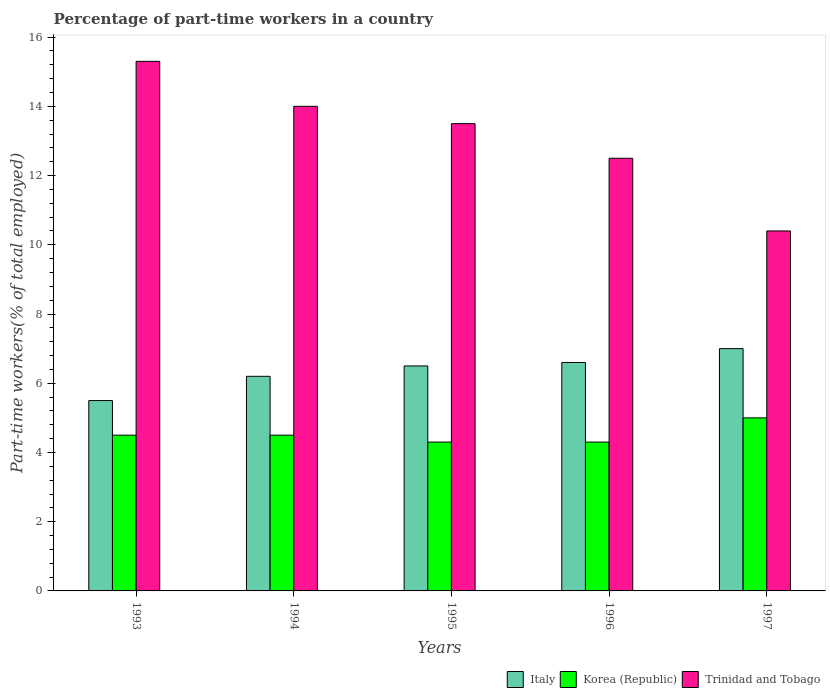How many different coloured bars are there?
Your answer should be compact. 3. How many groups of bars are there?
Give a very brief answer. 5. How many bars are there on the 3rd tick from the left?
Provide a short and direct response. 3. How many bars are there on the 2nd tick from the right?
Your answer should be very brief. 3. In how many cases, is the number of bars for a given year not equal to the number of legend labels?
Keep it short and to the point. 0. Across all years, what is the maximum percentage of part-time workers in Korea (Republic)?
Make the answer very short. 5. Across all years, what is the minimum percentage of part-time workers in Korea (Republic)?
Give a very brief answer. 4.3. In which year was the percentage of part-time workers in Korea (Republic) maximum?
Provide a succinct answer. 1997. In which year was the percentage of part-time workers in Trinidad and Tobago minimum?
Provide a succinct answer. 1997. What is the total percentage of part-time workers in Italy in the graph?
Make the answer very short. 31.8. What is the difference between the percentage of part-time workers in Korea (Republic) in 1993 and that in 1997?
Keep it short and to the point. -0.5. What is the average percentage of part-time workers in Korea (Republic) per year?
Give a very brief answer. 4.52. In the year 1997, what is the difference between the percentage of part-time workers in Italy and percentage of part-time workers in Trinidad and Tobago?
Keep it short and to the point. -3.4. In how many years, is the percentage of part-time workers in Trinidad and Tobago greater than 0.4 %?
Keep it short and to the point. 5. What is the ratio of the percentage of part-time workers in Korea (Republic) in 1993 to that in 1995?
Offer a terse response. 1.05. Is the percentage of part-time workers in Italy in 1993 less than that in 1996?
Your answer should be compact. Yes. Is the difference between the percentage of part-time workers in Italy in 1993 and 1996 greater than the difference between the percentage of part-time workers in Trinidad and Tobago in 1993 and 1996?
Provide a succinct answer. No. What is the difference between the highest and the second highest percentage of part-time workers in Italy?
Make the answer very short. 0.4. What is the difference between the highest and the lowest percentage of part-time workers in Korea (Republic)?
Ensure brevity in your answer.  0.7. What does the 3rd bar from the left in 1997 represents?
Ensure brevity in your answer.  Trinidad and Tobago. What does the 1st bar from the right in 1993 represents?
Offer a very short reply. Trinidad and Tobago. Is it the case that in every year, the sum of the percentage of part-time workers in Korea (Republic) and percentage of part-time workers in Trinidad and Tobago is greater than the percentage of part-time workers in Italy?
Your answer should be compact. Yes. How many bars are there?
Your answer should be compact. 15. What is the difference between two consecutive major ticks on the Y-axis?
Offer a very short reply. 2. Are the values on the major ticks of Y-axis written in scientific E-notation?
Ensure brevity in your answer.  No. Does the graph contain any zero values?
Keep it short and to the point. No. Where does the legend appear in the graph?
Your answer should be very brief. Bottom right. What is the title of the graph?
Your answer should be very brief. Percentage of part-time workers in a country. What is the label or title of the Y-axis?
Make the answer very short. Part-time workers(% of total employed). What is the Part-time workers(% of total employed) in Italy in 1993?
Give a very brief answer. 5.5. What is the Part-time workers(% of total employed) of Korea (Republic) in 1993?
Your answer should be very brief. 4.5. What is the Part-time workers(% of total employed) of Trinidad and Tobago in 1993?
Offer a terse response. 15.3. What is the Part-time workers(% of total employed) of Italy in 1994?
Make the answer very short. 6.2. What is the Part-time workers(% of total employed) of Korea (Republic) in 1995?
Provide a short and direct response. 4.3. What is the Part-time workers(% of total employed) of Trinidad and Tobago in 1995?
Provide a succinct answer. 13.5. What is the Part-time workers(% of total employed) of Italy in 1996?
Offer a very short reply. 6.6. What is the Part-time workers(% of total employed) in Korea (Republic) in 1996?
Offer a very short reply. 4.3. What is the Part-time workers(% of total employed) of Korea (Republic) in 1997?
Ensure brevity in your answer.  5. What is the Part-time workers(% of total employed) in Trinidad and Tobago in 1997?
Offer a very short reply. 10.4. Across all years, what is the maximum Part-time workers(% of total employed) of Korea (Republic)?
Offer a terse response. 5. Across all years, what is the maximum Part-time workers(% of total employed) of Trinidad and Tobago?
Ensure brevity in your answer.  15.3. Across all years, what is the minimum Part-time workers(% of total employed) in Korea (Republic)?
Provide a short and direct response. 4.3. Across all years, what is the minimum Part-time workers(% of total employed) of Trinidad and Tobago?
Make the answer very short. 10.4. What is the total Part-time workers(% of total employed) in Italy in the graph?
Your answer should be compact. 31.8. What is the total Part-time workers(% of total employed) of Korea (Republic) in the graph?
Give a very brief answer. 22.6. What is the total Part-time workers(% of total employed) in Trinidad and Tobago in the graph?
Your answer should be compact. 65.7. What is the difference between the Part-time workers(% of total employed) in Italy in 1993 and that in 1994?
Your answer should be very brief. -0.7. What is the difference between the Part-time workers(% of total employed) of Korea (Republic) in 1993 and that in 1994?
Ensure brevity in your answer.  0. What is the difference between the Part-time workers(% of total employed) in Trinidad and Tobago in 1993 and that in 1994?
Keep it short and to the point. 1.3. What is the difference between the Part-time workers(% of total employed) in Korea (Republic) in 1993 and that in 1995?
Make the answer very short. 0.2. What is the difference between the Part-time workers(% of total employed) in Italy in 1993 and that in 1996?
Offer a very short reply. -1.1. What is the difference between the Part-time workers(% of total employed) in Korea (Republic) in 1993 and that in 1996?
Give a very brief answer. 0.2. What is the difference between the Part-time workers(% of total employed) of Trinidad and Tobago in 1993 and that in 1996?
Make the answer very short. 2.8. What is the difference between the Part-time workers(% of total employed) of Italy in 1993 and that in 1997?
Ensure brevity in your answer.  -1.5. What is the difference between the Part-time workers(% of total employed) in Italy in 1994 and that in 1995?
Make the answer very short. -0.3. What is the difference between the Part-time workers(% of total employed) in Italy in 1994 and that in 1996?
Your response must be concise. -0.4. What is the difference between the Part-time workers(% of total employed) of Korea (Republic) in 1994 and that in 1996?
Your answer should be compact. 0.2. What is the difference between the Part-time workers(% of total employed) of Korea (Republic) in 1994 and that in 1997?
Make the answer very short. -0.5. What is the difference between the Part-time workers(% of total employed) of Trinidad and Tobago in 1994 and that in 1997?
Ensure brevity in your answer.  3.6. What is the difference between the Part-time workers(% of total employed) in Italy in 1995 and that in 1996?
Offer a very short reply. -0.1. What is the difference between the Part-time workers(% of total employed) of Korea (Republic) in 1995 and that in 1997?
Offer a terse response. -0.7. What is the difference between the Part-time workers(% of total employed) of Trinidad and Tobago in 1995 and that in 1997?
Provide a short and direct response. 3.1. What is the difference between the Part-time workers(% of total employed) in Trinidad and Tobago in 1996 and that in 1997?
Make the answer very short. 2.1. What is the difference between the Part-time workers(% of total employed) of Italy in 1993 and the Part-time workers(% of total employed) of Korea (Republic) in 1994?
Your answer should be very brief. 1. What is the difference between the Part-time workers(% of total employed) in Italy in 1993 and the Part-time workers(% of total employed) in Trinidad and Tobago in 1994?
Make the answer very short. -8.5. What is the difference between the Part-time workers(% of total employed) in Korea (Republic) in 1993 and the Part-time workers(% of total employed) in Trinidad and Tobago in 1994?
Offer a very short reply. -9.5. What is the difference between the Part-time workers(% of total employed) of Korea (Republic) in 1993 and the Part-time workers(% of total employed) of Trinidad and Tobago in 1995?
Provide a short and direct response. -9. What is the difference between the Part-time workers(% of total employed) of Italy in 1993 and the Part-time workers(% of total employed) of Korea (Republic) in 1996?
Offer a terse response. 1.2. What is the difference between the Part-time workers(% of total employed) of Italy in 1993 and the Part-time workers(% of total employed) of Trinidad and Tobago in 1996?
Give a very brief answer. -7. What is the difference between the Part-time workers(% of total employed) of Korea (Republic) in 1993 and the Part-time workers(% of total employed) of Trinidad and Tobago in 1996?
Your answer should be very brief. -8. What is the difference between the Part-time workers(% of total employed) of Italy in 1993 and the Part-time workers(% of total employed) of Korea (Republic) in 1997?
Keep it short and to the point. 0.5. What is the difference between the Part-time workers(% of total employed) of Korea (Republic) in 1993 and the Part-time workers(% of total employed) of Trinidad and Tobago in 1997?
Make the answer very short. -5.9. What is the difference between the Part-time workers(% of total employed) in Italy in 1994 and the Part-time workers(% of total employed) in Trinidad and Tobago in 1995?
Ensure brevity in your answer.  -7.3. What is the difference between the Part-time workers(% of total employed) in Korea (Republic) in 1994 and the Part-time workers(% of total employed) in Trinidad and Tobago in 1995?
Give a very brief answer. -9. What is the difference between the Part-time workers(% of total employed) in Italy in 1994 and the Part-time workers(% of total employed) in Korea (Republic) in 1996?
Make the answer very short. 1.9. What is the difference between the Part-time workers(% of total employed) of Italy in 1994 and the Part-time workers(% of total employed) of Trinidad and Tobago in 1997?
Your answer should be very brief. -4.2. What is the difference between the Part-time workers(% of total employed) in Italy in 1995 and the Part-time workers(% of total employed) in Korea (Republic) in 1996?
Offer a terse response. 2.2. What is the difference between the Part-time workers(% of total employed) of Italy in 1995 and the Part-time workers(% of total employed) of Korea (Republic) in 1997?
Your response must be concise. 1.5. What is the difference between the Part-time workers(% of total employed) in Italy in 1995 and the Part-time workers(% of total employed) in Trinidad and Tobago in 1997?
Offer a terse response. -3.9. What is the difference between the Part-time workers(% of total employed) in Korea (Republic) in 1995 and the Part-time workers(% of total employed) in Trinidad and Tobago in 1997?
Your answer should be compact. -6.1. What is the difference between the Part-time workers(% of total employed) in Italy in 1996 and the Part-time workers(% of total employed) in Korea (Republic) in 1997?
Make the answer very short. 1.6. What is the difference between the Part-time workers(% of total employed) of Korea (Republic) in 1996 and the Part-time workers(% of total employed) of Trinidad and Tobago in 1997?
Your response must be concise. -6.1. What is the average Part-time workers(% of total employed) in Italy per year?
Offer a terse response. 6.36. What is the average Part-time workers(% of total employed) in Korea (Republic) per year?
Offer a terse response. 4.52. What is the average Part-time workers(% of total employed) in Trinidad and Tobago per year?
Ensure brevity in your answer.  13.14. In the year 1993, what is the difference between the Part-time workers(% of total employed) of Italy and Part-time workers(% of total employed) of Korea (Republic)?
Your response must be concise. 1. In the year 1993, what is the difference between the Part-time workers(% of total employed) of Korea (Republic) and Part-time workers(% of total employed) of Trinidad and Tobago?
Offer a very short reply. -10.8. In the year 1994, what is the difference between the Part-time workers(% of total employed) of Italy and Part-time workers(% of total employed) of Korea (Republic)?
Offer a terse response. 1.7. In the year 1994, what is the difference between the Part-time workers(% of total employed) in Italy and Part-time workers(% of total employed) in Trinidad and Tobago?
Provide a short and direct response. -7.8. In the year 1994, what is the difference between the Part-time workers(% of total employed) in Korea (Republic) and Part-time workers(% of total employed) in Trinidad and Tobago?
Give a very brief answer. -9.5. In the year 1995, what is the difference between the Part-time workers(% of total employed) in Italy and Part-time workers(% of total employed) in Korea (Republic)?
Make the answer very short. 2.2. In the year 1995, what is the difference between the Part-time workers(% of total employed) of Italy and Part-time workers(% of total employed) of Trinidad and Tobago?
Give a very brief answer. -7. In the year 1995, what is the difference between the Part-time workers(% of total employed) of Korea (Republic) and Part-time workers(% of total employed) of Trinidad and Tobago?
Give a very brief answer. -9.2. In the year 1996, what is the difference between the Part-time workers(% of total employed) of Korea (Republic) and Part-time workers(% of total employed) of Trinidad and Tobago?
Provide a succinct answer. -8.2. In the year 1997, what is the difference between the Part-time workers(% of total employed) in Italy and Part-time workers(% of total employed) in Korea (Republic)?
Give a very brief answer. 2. What is the ratio of the Part-time workers(% of total employed) in Italy in 1993 to that in 1994?
Keep it short and to the point. 0.89. What is the ratio of the Part-time workers(% of total employed) in Korea (Republic) in 1993 to that in 1994?
Provide a succinct answer. 1. What is the ratio of the Part-time workers(% of total employed) of Trinidad and Tobago in 1993 to that in 1994?
Ensure brevity in your answer.  1.09. What is the ratio of the Part-time workers(% of total employed) in Italy in 1993 to that in 1995?
Provide a short and direct response. 0.85. What is the ratio of the Part-time workers(% of total employed) in Korea (Republic) in 1993 to that in 1995?
Make the answer very short. 1.05. What is the ratio of the Part-time workers(% of total employed) in Trinidad and Tobago in 1993 to that in 1995?
Your answer should be very brief. 1.13. What is the ratio of the Part-time workers(% of total employed) of Korea (Republic) in 1993 to that in 1996?
Offer a terse response. 1.05. What is the ratio of the Part-time workers(% of total employed) of Trinidad and Tobago in 1993 to that in 1996?
Your answer should be very brief. 1.22. What is the ratio of the Part-time workers(% of total employed) in Italy in 1993 to that in 1997?
Ensure brevity in your answer.  0.79. What is the ratio of the Part-time workers(% of total employed) of Korea (Republic) in 1993 to that in 1997?
Offer a terse response. 0.9. What is the ratio of the Part-time workers(% of total employed) of Trinidad and Tobago in 1993 to that in 1997?
Provide a succinct answer. 1.47. What is the ratio of the Part-time workers(% of total employed) of Italy in 1994 to that in 1995?
Provide a short and direct response. 0.95. What is the ratio of the Part-time workers(% of total employed) in Korea (Republic) in 1994 to that in 1995?
Make the answer very short. 1.05. What is the ratio of the Part-time workers(% of total employed) in Trinidad and Tobago in 1994 to that in 1995?
Offer a terse response. 1.04. What is the ratio of the Part-time workers(% of total employed) of Italy in 1994 to that in 1996?
Offer a terse response. 0.94. What is the ratio of the Part-time workers(% of total employed) of Korea (Republic) in 1994 to that in 1996?
Your answer should be very brief. 1.05. What is the ratio of the Part-time workers(% of total employed) of Trinidad and Tobago in 1994 to that in 1996?
Your answer should be very brief. 1.12. What is the ratio of the Part-time workers(% of total employed) of Italy in 1994 to that in 1997?
Offer a very short reply. 0.89. What is the ratio of the Part-time workers(% of total employed) of Trinidad and Tobago in 1994 to that in 1997?
Offer a terse response. 1.35. What is the ratio of the Part-time workers(% of total employed) of Italy in 1995 to that in 1996?
Your answer should be compact. 0.98. What is the ratio of the Part-time workers(% of total employed) in Korea (Republic) in 1995 to that in 1997?
Make the answer very short. 0.86. What is the ratio of the Part-time workers(% of total employed) of Trinidad and Tobago in 1995 to that in 1997?
Provide a succinct answer. 1.3. What is the ratio of the Part-time workers(% of total employed) in Italy in 1996 to that in 1997?
Make the answer very short. 0.94. What is the ratio of the Part-time workers(% of total employed) of Korea (Republic) in 1996 to that in 1997?
Give a very brief answer. 0.86. What is the ratio of the Part-time workers(% of total employed) in Trinidad and Tobago in 1996 to that in 1997?
Ensure brevity in your answer.  1.2. What is the difference between the highest and the second highest Part-time workers(% of total employed) in Trinidad and Tobago?
Provide a short and direct response. 1.3. What is the difference between the highest and the lowest Part-time workers(% of total employed) in Italy?
Keep it short and to the point. 1.5. 